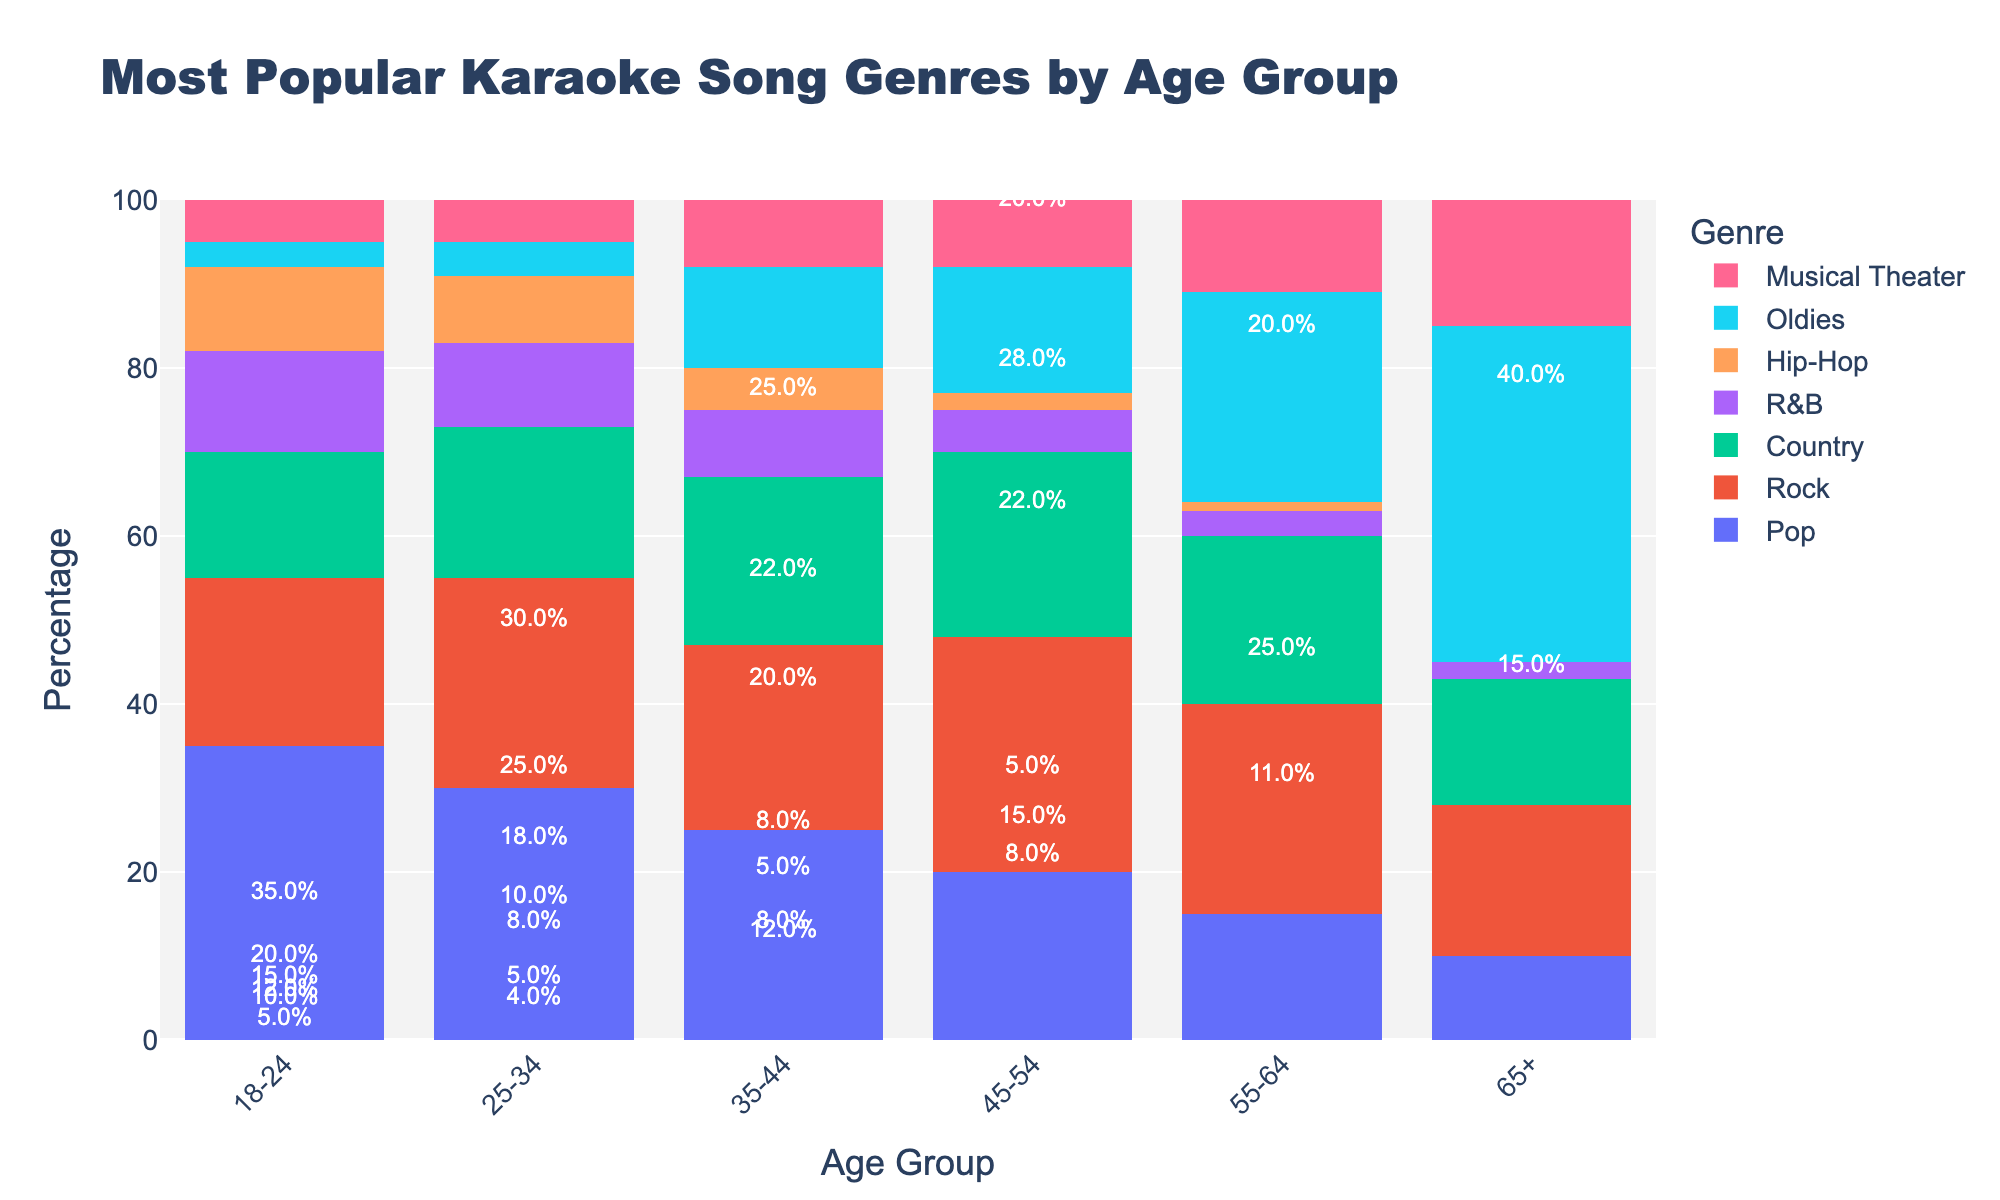Which age group prefers Hip-Hop the most? The height of the bar representing Hip-Hop is the tallest in the 18-24 age group, implying the highest percentage for that genre in that age range.
Answer: 18-24 What is the total percentage of Pop and Rock preferred by the 25-34 age group? The height of the Pop bar in the 25-34 age group is 30, and the Rock bar is 25. Summing these gives 30 + 25 = 55.
Answer: 55% Among age groups 45-54 and 55-64, which group shows a higher preference for Country music? By comparing the heights of the Country bars, the 45-54 age group has a bar height of 22, while the 55-64 age group has a bar height of 20. 22 is greater than 20.
Answer: 45-54 What is the difference in preference for Oldies between the 18-24 and 65+ age groups? The Oldies bar for the 18-24 age group is at 3%, and for the 65+ age group, it is at 40%. The absolute difference is 40 - 3 = 37.
Answer: 37% Which genre shows the least preference in the 55-64 age group and what percentage? Looking at the bar chart for the 55-64 age group, the smallest bar corresponds to Hip-Hop with a height of 1%.
Answer: Hip-Hop, 1% For the 35-44 age group, what is the average preference percentage for all genres? Sum all percentages for the 35-44 age group and divide by the number of genres:
  (25 + 22 + 20 + 8 + 5 + 12 + 8) / 7 = 100 / 7 ≈ 14.29.
Answer: Approximately 14.3% Which age group has the smallest variation in genre preferences? Observing the spread of bar heights closely, the 25-34 age group has bars ranging from about 4% to 30%, showing a relatively smaller range compared to others.
Answer: 25-34 Is there any genre that all age groups seem to enjoy similarly and what is it? By comparing the heights of the bars for each genre across all age groups, Musical Theater has relatively similar heights, ranging from 5 to 15, indicating similar enjoyment across age groups.
Answer: Musical Theater 